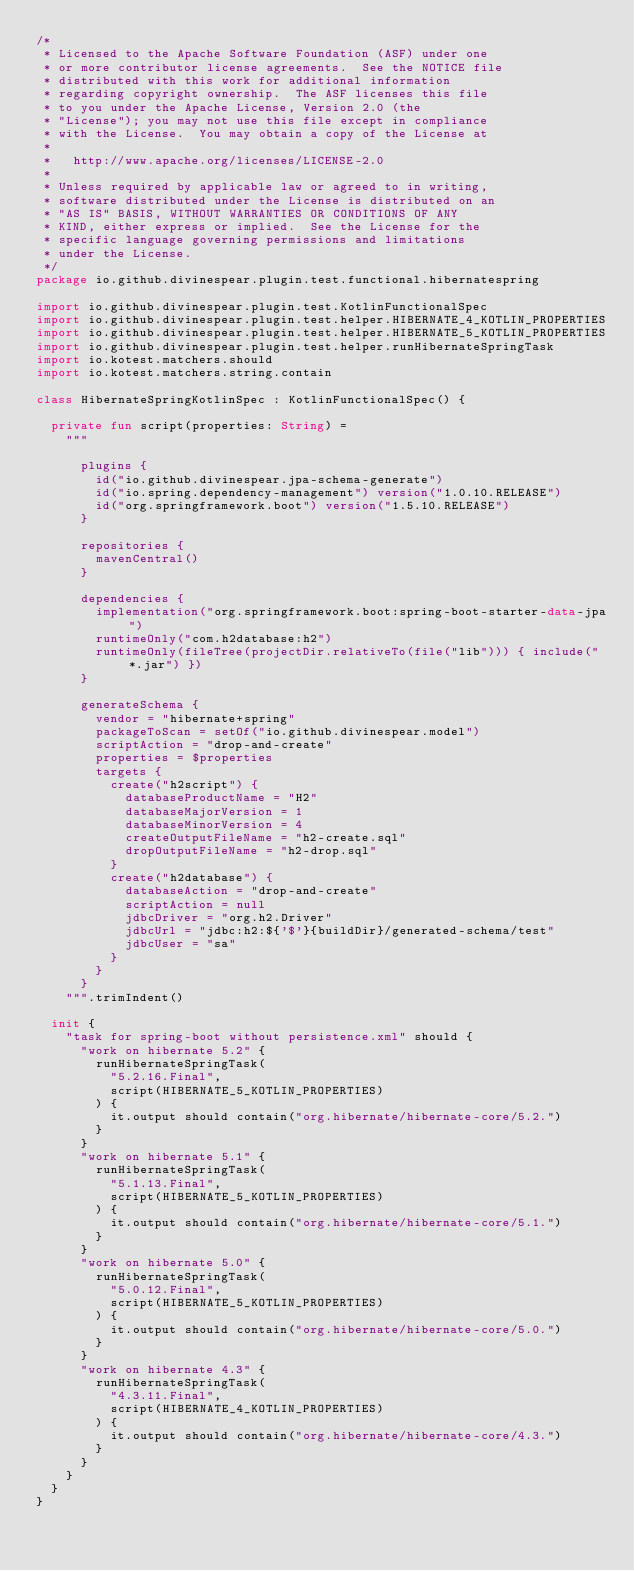<code> <loc_0><loc_0><loc_500><loc_500><_Kotlin_>/*
 * Licensed to the Apache Software Foundation (ASF) under one
 * or more contributor license agreements.  See the NOTICE file
 * distributed with this work for additional information
 * regarding copyright ownership.  The ASF licenses this file
 * to you under the Apache License, Version 2.0 (the
 * "License"); you may not use this file except in compliance
 * with the License.  You may obtain a copy of the License at
 *
 *   http://www.apache.org/licenses/LICENSE-2.0
 *
 * Unless required by applicable law or agreed to in writing,
 * software distributed under the License is distributed on an
 * "AS IS" BASIS, WITHOUT WARRANTIES OR CONDITIONS OF ANY
 * KIND, either express or implied.  See the License for the
 * specific language governing permissions and limitations
 * under the License.
 */
package io.github.divinespear.plugin.test.functional.hibernatespring

import io.github.divinespear.plugin.test.KotlinFunctionalSpec
import io.github.divinespear.plugin.test.helper.HIBERNATE_4_KOTLIN_PROPERTIES
import io.github.divinespear.plugin.test.helper.HIBERNATE_5_KOTLIN_PROPERTIES
import io.github.divinespear.plugin.test.helper.runHibernateSpringTask
import io.kotest.matchers.should
import io.kotest.matchers.string.contain

class HibernateSpringKotlinSpec : KotlinFunctionalSpec() {

  private fun script(properties: String) =
    """
      
      plugins {
        id("io.github.divinespear.jpa-schema-generate")
        id("io.spring.dependency-management") version("1.0.10.RELEASE")
        id("org.springframework.boot") version("1.5.10.RELEASE")
      }
      
      repositories {
        mavenCentral()
      }
      
      dependencies {
        implementation("org.springframework.boot:spring-boot-starter-data-jpa")
        runtimeOnly("com.h2database:h2")
        runtimeOnly(fileTree(projectDir.relativeTo(file("lib"))) { include("*.jar") })
      }
      
      generateSchema {
        vendor = "hibernate+spring"
        packageToScan = setOf("io.github.divinespear.model")
        scriptAction = "drop-and-create"
        properties = $properties
        targets {
          create("h2script") {
            databaseProductName = "H2"
            databaseMajorVersion = 1
            databaseMinorVersion = 4
            createOutputFileName = "h2-create.sql"
            dropOutputFileName = "h2-drop.sql"
          }
          create("h2database") {
            databaseAction = "drop-and-create"
            scriptAction = null
            jdbcDriver = "org.h2.Driver"
            jdbcUrl = "jdbc:h2:${'$'}{buildDir}/generated-schema/test"
            jdbcUser = "sa"
          }
        }
      }
    """.trimIndent()

  init {
    "task for spring-boot without persistence.xml" should {
      "work on hibernate 5.2" {
        runHibernateSpringTask(
          "5.2.16.Final",
          script(HIBERNATE_5_KOTLIN_PROPERTIES)
        ) {
          it.output should contain("org.hibernate/hibernate-core/5.2.")
        }
      }
      "work on hibernate 5.1" {
        runHibernateSpringTask(
          "5.1.13.Final",
          script(HIBERNATE_5_KOTLIN_PROPERTIES)
        ) {
          it.output should contain("org.hibernate/hibernate-core/5.1.")
        }
      }
      "work on hibernate 5.0" {
        runHibernateSpringTask(
          "5.0.12.Final",
          script(HIBERNATE_5_KOTLIN_PROPERTIES)
        ) {
          it.output should contain("org.hibernate/hibernate-core/5.0.")
        }
      }
      "work on hibernate 4.3" {
        runHibernateSpringTask(
          "4.3.11.Final",
          script(HIBERNATE_4_KOTLIN_PROPERTIES)
        ) {
          it.output should contain("org.hibernate/hibernate-core/4.3.")
        }
      }
    }
  }
}
</code> 